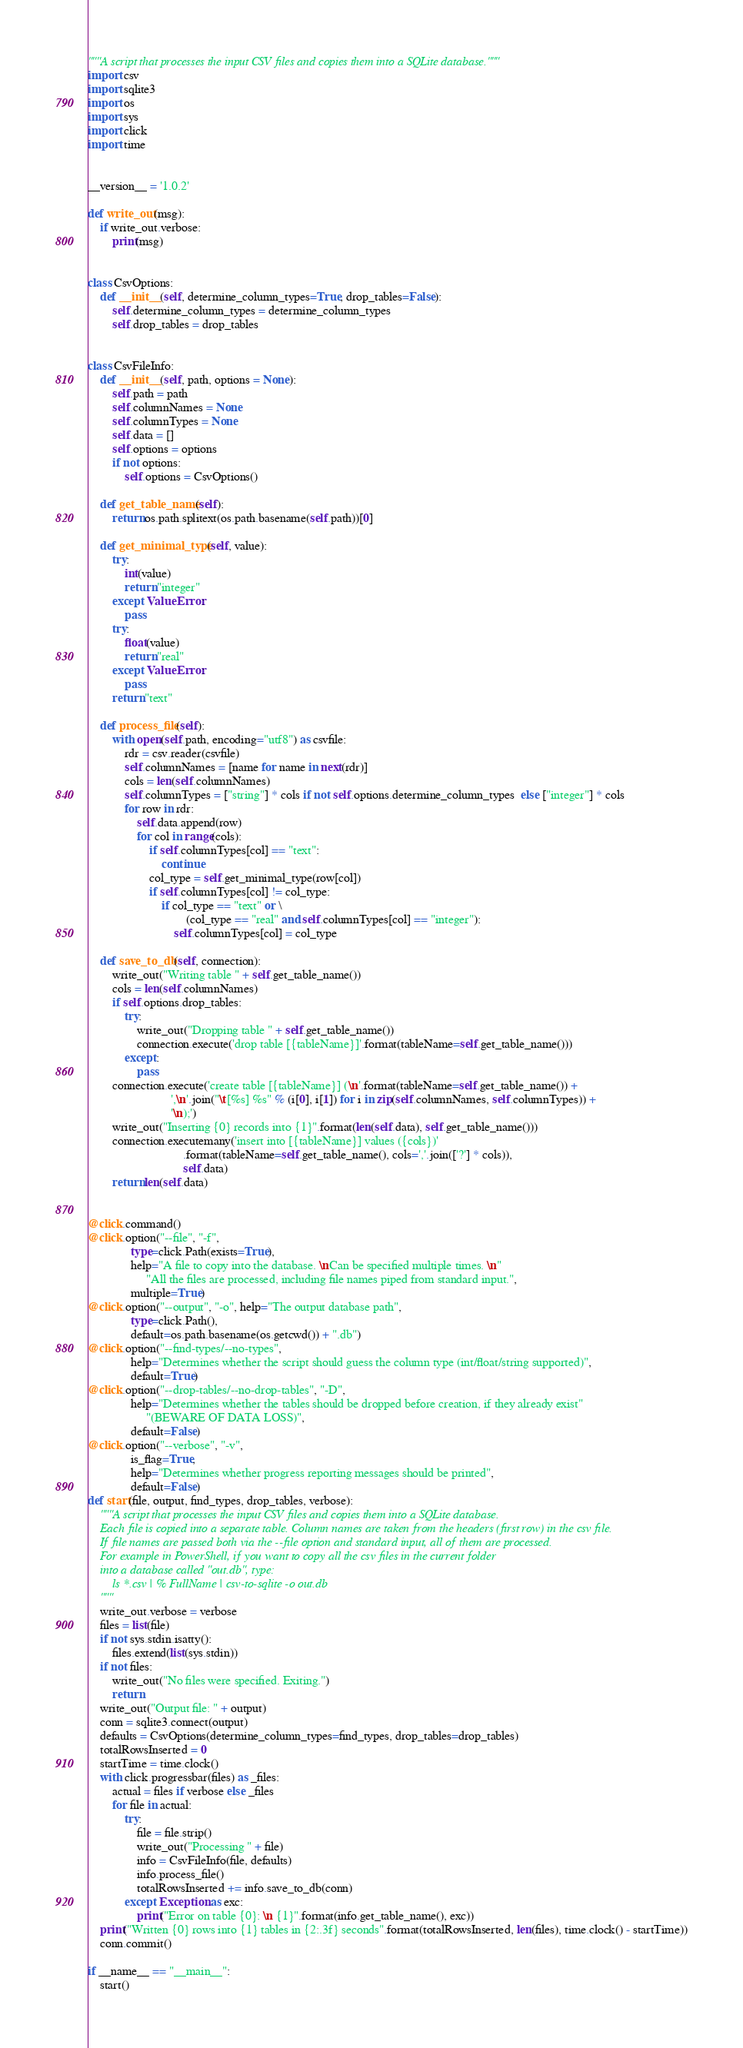Convert code to text. <code><loc_0><loc_0><loc_500><loc_500><_Python_>"""A script that processes the input CSV files and copies them into a SQLite database."""
import csv
import sqlite3
import os
import sys
import click
import time


__version__ = '1.0.2'

def write_out(msg):
    if write_out.verbose:
        print(msg)


class CsvOptions:
    def __init__(self, determine_column_types=True, drop_tables=False):
        self.determine_column_types = determine_column_types
        self.drop_tables = drop_tables


class CsvFileInfo:
    def __init__(self, path, options = None):
        self.path = path
        self.columnNames = None
        self.columnTypes = None
        self.data = []
        self.options = options
        if not options:
            self.options = CsvOptions()

    def get_table_name(self):
        return os.path.splitext(os.path.basename(self.path))[0]

    def get_minimal_type(self, value):
        try:
            int(value)
            return "integer"
        except ValueError:
            pass
        try:
            float(value)
            return "real"
        except ValueError:
            pass
        return "text"

    def process_file(self):
        with open(self.path, encoding="utf8") as csvfile:
            rdr = csv.reader(csvfile)
            self.columnNames = [name for name in next(rdr)]
            cols = len(self.columnNames)
            self.columnTypes = ["string"] * cols if not self.options.determine_column_types  else ["integer"] * cols
            for row in rdr:
                self.data.append(row)
                for col in range(cols):
                    if self.columnTypes[col] == "text":
                        continue
                    col_type = self.get_minimal_type(row[col])
                    if self.columnTypes[col] != col_type:
                        if col_type == "text" or \
                                (col_type == "real" and self.columnTypes[col] == "integer"):
                            self.columnTypes[col] = col_type

    def save_to_db(self, connection):
        write_out("Writing table " + self.get_table_name())
        cols = len(self.columnNames)
        if self.options.drop_tables:
            try:
                write_out("Dropping table " + self.get_table_name())
                connection.execute('drop table [{tableName}]'.format(tableName=self.get_table_name()))
            except:
                pass
        connection.execute('create table [{tableName}] (\n'.format(tableName=self.get_table_name()) +
                           ',\n'.join("\t[%s] %s" % (i[0], i[1]) for i in zip(self.columnNames, self.columnTypes)) +
                           '\n);')
        write_out("Inserting {0} records into {1}".format(len(self.data), self.get_table_name()))
        connection.executemany('insert into [{tableName}] values ({cols})'
                               .format(tableName=self.get_table_name(), cols=','.join(['?'] * cols)),
                               self.data)
        return len(self.data)


@click.command()
@click.option("--file", "-f",
              type=click.Path(exists=True),
              help="A file to copy into the database. \nCan be specified multiple times. \n"
                   "All the files are processed, including file names piped from standard input.",
              multiple=True)
@click.option("--output", "-o", help="The output database path",
              type=click.Path(),
              default=os.path.basename(os.getcwd()) + ".db")
@click.option("--find-types/--no-types",
              help="Determines whether the script should guess the column type (int/float/string supported)",
              default=True)
@click.option("--drop-tables/--no-drop-tables", "-D",
              help="Determines whether the tables should be dropped before creation, if they already exist"
                   "(BEWARE OF DATA LOSS)",
              default=False)
@click.option("--verbose", "-v",
              is_flag=True,
              help="Determines whether progress reporting messages should be printed",
              default=False)
def start(file, output, find_types, drop_tables, verbose):
    """A script that processes the input CSV files and copies them into a SQLite database.
    Each file is copied into a separate table. Column names are taken from the headers (first row) in the csv file.
    If file names are passed both via the --file option and standard input, all of them are processed.
    For example in PowerShell, if you want to copy all the csv files in the current folder
    into a database called "out.db", type:
        ls *.csv | % FullName | csv-to-sqlite -o out.db
    """
    write_out.verbose = verbose
    files = list(file)
    if not sys.stdin.isatty():
        files.extend(list(sys.stdin))
    if not files:
        write_out("No files were specified. Exiting.")
        return
    write_out("Output file: " + output)
    conn = sqlite3.connect(output)
    defaults = CsvOptions(determine_column_types=find_types, drop_tables=drop_tables)
    totalRowsInserted = 0
    startTime = time.clock()
    with click.progressbar(files) as _files:
        actual = files if verbose else _files
        for file in actual:
            try:
                file = file.strip()
                write_out("Processing " + file)
                info = CsvFileInfo(file, defaults)
                info.process_file()
                totalRowsInserted += info.save_to_db(conn)
            except Exception as exc:
                print("Error on table {0}: \n {1}".format(info.get_table_name(), exc))
    print("Written {0} rows into {1} tables in {2:.3f} seconds".format(totalRowsInserted, len(files), time.clock() - startTime))
    conn.commit()

if __name__ == "__main__":
    start()</code> 